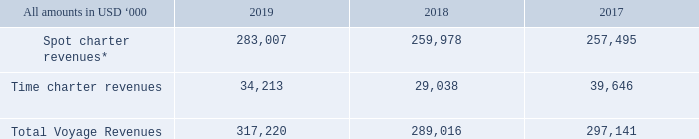3. VOYAGE REVENUES
Our voyage revenues consist of time charter revenues and spot charter revenues with the following split:
*Spot charter revenues for 2019 and 2018 are presented in accordance we ASC 606 Revenue from Contracts with Customers. The comparative information for 2017 has not been restated.
What are the respective spot charter revenues in 2018 and 2019?
Answer scale should be: thousand. 259,978, 283,007. What are the respective time charter revenues in 2018 and 2019?
Answer scale should be: thousand. 29,038, 34,213. What are the respective total voyage revenues in 2018 and 2019?
Answer scale should be: thousand. 289,016, 317,220. What is the value of the 2019 spot charter revenues as a percentage of the 2018 spot charter revenues?
Answer scale should be: percent. 283,007/259,978 
Answer: 108.86. What is the value of the 2019 time charter revenues as a percentage of the 2018 time charter revenues?
Answer scale should be: percent. 34,213/29,038 
Answer: 117.82. What is the value of the 2019 total voyage revenue as a percentage of the 2018 total voyage revenues?
Answer scale should be: percent. 317,220/289,016 
Answer: 109.76. 